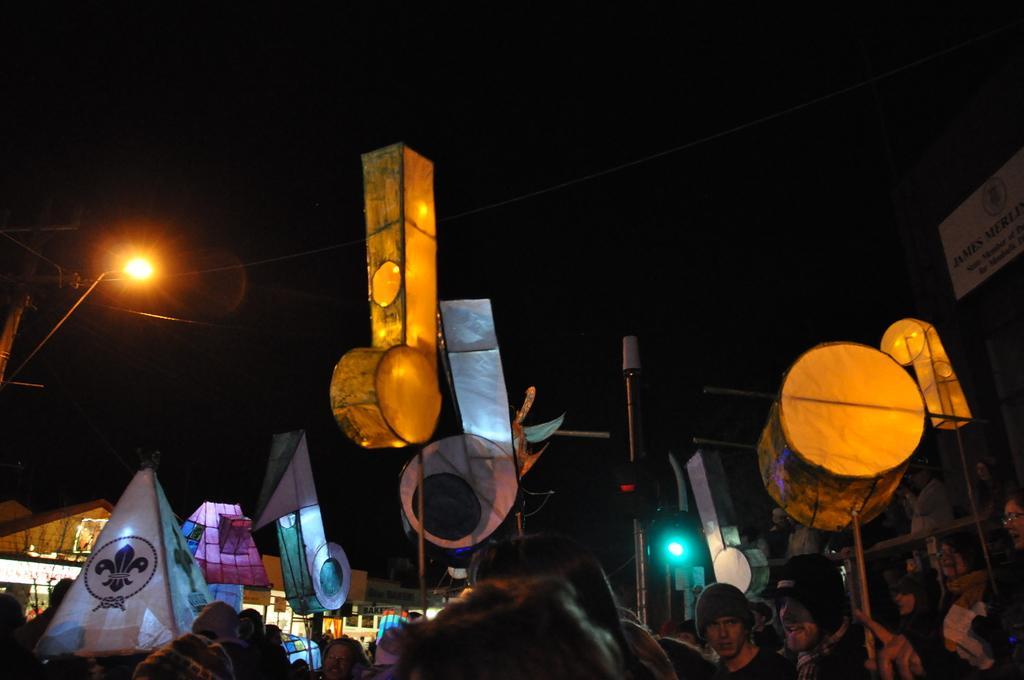Can you describe this image briefly? In the picture we can see some group of persons standing, there are some objects and top of the picture there is dark sky. 